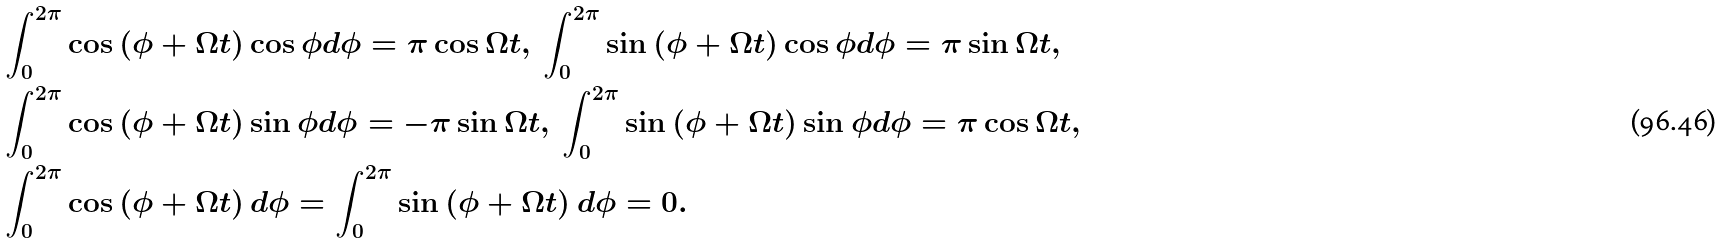<formula> <loc_0><loc_0><loc_500><loc_500>& \int _ { 0 } ^ { 2 \pi } \cos \left ( \phi + \Omega t \right ) \cos \phi d \phi = \pi \cos \Omega t , \, \int _ { 0 } ^ { 2 \pi } \sin \left ( \phi + \Omega t \right ) \cos \phi d \phi = \pi \sin \Omega t , \\ & \int _ { 0 } ^ { 2 \pi } \cos \left ( \phi + \Omega t \right ) \sin \phi d \phi = - \pi \sin \Omega t , \, \int _ { 0 } ^ { 2 \pi } \sin \left ( \phi + \Omega t \right ) \sin \phi d \phi = \pi \cos \Omega t , \\ & \int _ { 0 } ^ { 2 \pi } \cos \left ( \phi + \Omega t \right ) d \phi = \int _ { 0 } ^ { 2 \pi } \sin \left ( \phi + \Omega t \right ) d \phi = 0 .</formula> 